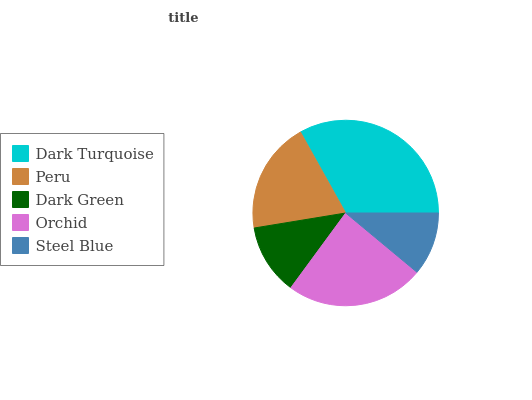Is Steel Blue the minimum?
Answer yes or no. Yes. Is Dark Turquoise the maximum?
Answer yes or no. Yes. Is Peru the minimum?
Answer yes or no. No. Is Peru the maximum?
Answer yes or no. No. Is Dark Turquoise greater than Peru?
Answer yes or no. Yes. Is Peru less than Dark Turquoise?
Answer yes or no. Yes. Is Peru greater than Dark Turquoise?
Answer yes or no. No. Is Dark Turquoise less than Peru?
Answer yes or no. No. Is Peru the high median?
Answer yes or no. Yes. Is Peru the low median?
Answer yes or no. Yes. Is Dark Turquoise the high median?
Answer yes or no. No. Is Dark Green the low median?
Answer yes or no. No. 